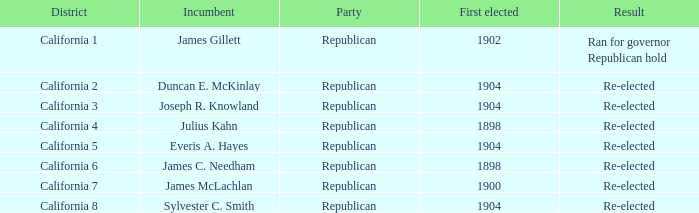Which District has a First Elected of 1904 and an Incumbent of Duncan E. Mckinlay? California 2. 